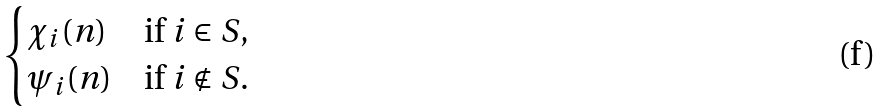Convert formula to latex. <formula><loc_0><loc_0><loc_500><loc_500>\begin{cases} \chi _ { i } ( n ) & \text {if } i \in S , \\ \psi _ { i } ( n ) & \text {if } i \notin S . \end{cases}</formula> 